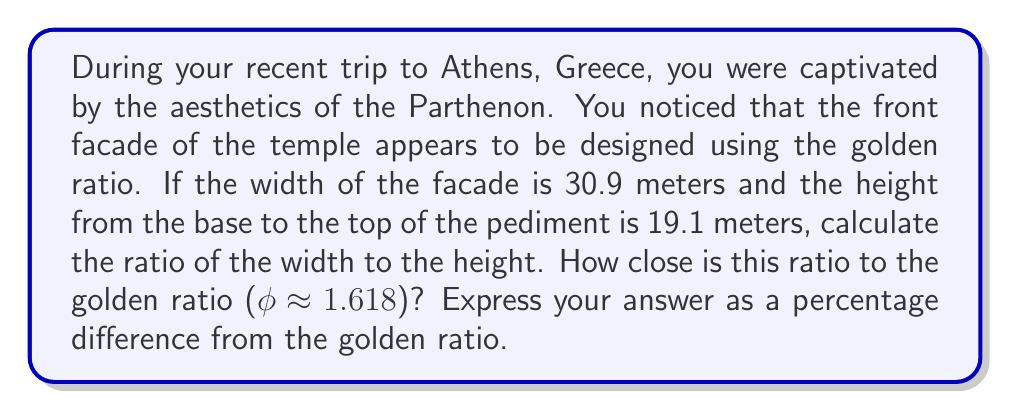Teach me how to tackle this problem. To solve this problem, we'll follow these steps:

1. Calculate the ratio of the width to the height of the Parthenon's facade.
2. Compare this ratio to the golden ratio.
3. Calculate the percentage difference.

Step 1: Calculate the ratio of width to height

$$ \text{Ratio} = \frac{\text{Width}}{\text{Height}} = \frac{30.9 \text{ m}}{19.1 \text{ m}} $$

$$ \text{Ratio} = 1.6178010471204188 $$

Step 2: Compare to the golden ratio

The golden ratio (φ) is approximately 1.618.

Step 3: Calculate the percentage difference

To calculate the percentage difference, we'll use the formula:

$$ \text{Percentage Difference} = \left|\frac{\text{Calculated Ratio} - \text{Golden Ratio}}{\text{Golden Ratio}}\right| \times 100\% $$

Substituting the values:

$$ \text{Percentage Difference} = \left|\frac{1.6178010471204188 - 1.618}{1.618}\right| \times 100\% $$

$$ = \left|\frac{-0.0001989528795812}{1.618}\right| \times 100\% $$

$$ = 0.0123\% $$

This extremely small percentage difference indicates that the Parthenon's facade dimensions are remarkably close to the golden ratio, demonstrating the ancient Greeks' attention to aesthetic proportions in their architecture.
Answer: The percentage difference between the calculated ratio and the golden ratio is 0.0123%. 